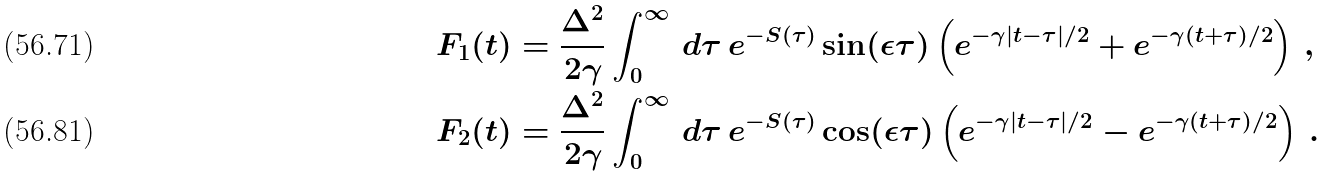Convert formula to latex. <formula><loc_0><loc_0><loc_500><loc_500>F _ { 1 } ( t ) & = \frac { \Delta ^ { 2 } } { 2 \gamma } \int _ { 0 } ^ { \infty } \, d \tau \, e ^ { - S ( \tau ) } \sin ( \epsilon \tau ) \left ( e ^ { - \gamma | t - \tau | / 2 } + e ^ { - \gamma ( t + \tau ) / 2 } \right ) \, , \\ F _ { 2 } ( t ) & = \frac { \Delta ^ { 2 } } { 2 \gamma } \int _ { 0 } ^ { \infty } \, d \tau \, e ^ { - S ( \tau ) } \cos ( \epsilon \tau ) \left ( e ^ { - \gamma | t - \tau | / 2 } - e ^ { - \gamma ( t + \tau ) / 2 } \right ) \, .</formula> 